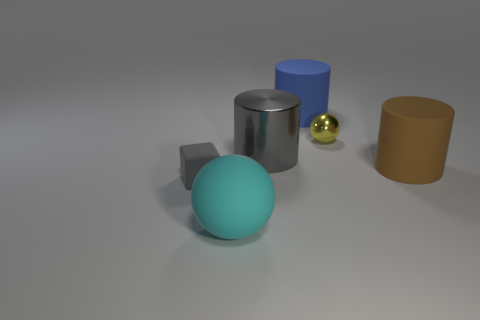Is there a gray object that has the same material as the small yellow ball?
Your response must be concise. Yes. What material is the yellow thing that is the same size as the rubber block?
Ensure brevity in your answer.  Metal. What material is the large brown cylinder that is behind the big rubber thing in front of the small gray cube?
Your answer should be compact. Rubber. Do the metal thing that is behind the big metal cylinder and the big cyan rubber thing have the same shape?
Your response must be concise. Yes. What is the color of the ball that is the same material as the block?
Provide a short and direct response. Cyan. There is a sphere that is right of the large cyan matte sphere; what is its material?
Give a very brief answer. Metal. Is the shape of the small metal thing the same as the big thing that is to the right of the small yellow metal thing?
Provide a succinct answer. No. The thing that is to the left of the blue matte cylinder and to the right of the cyan ball is made of what material?
Your answer should be compact. Metal. There is a rubber ball that is the same size as the gray shiny cylinder; what is its color?
Provide a succinct answer. Cyan. Do the large sphere and the big cylinder on the right side of the yellow ball have the same material?
Provide a short and direct response. Yes. 